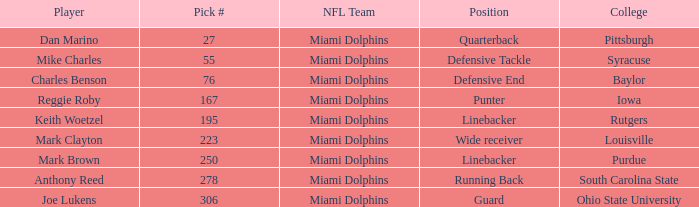If the Position is Running Back what is the Total number of Pick #? 1.0. 